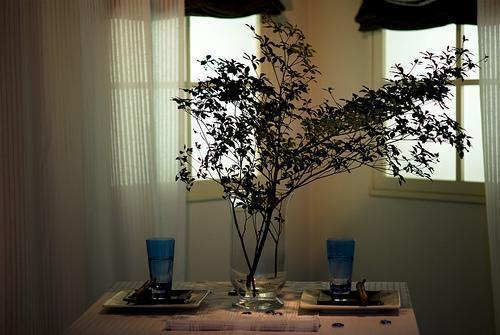How many glasses are there?
Give a very brief answer. 2. How many windows are shown?
Give a very brief answer. 2. How many placemats are there?
Give a very brief answer. 2. How many cups are there?
Give a very brief answer. 2. 